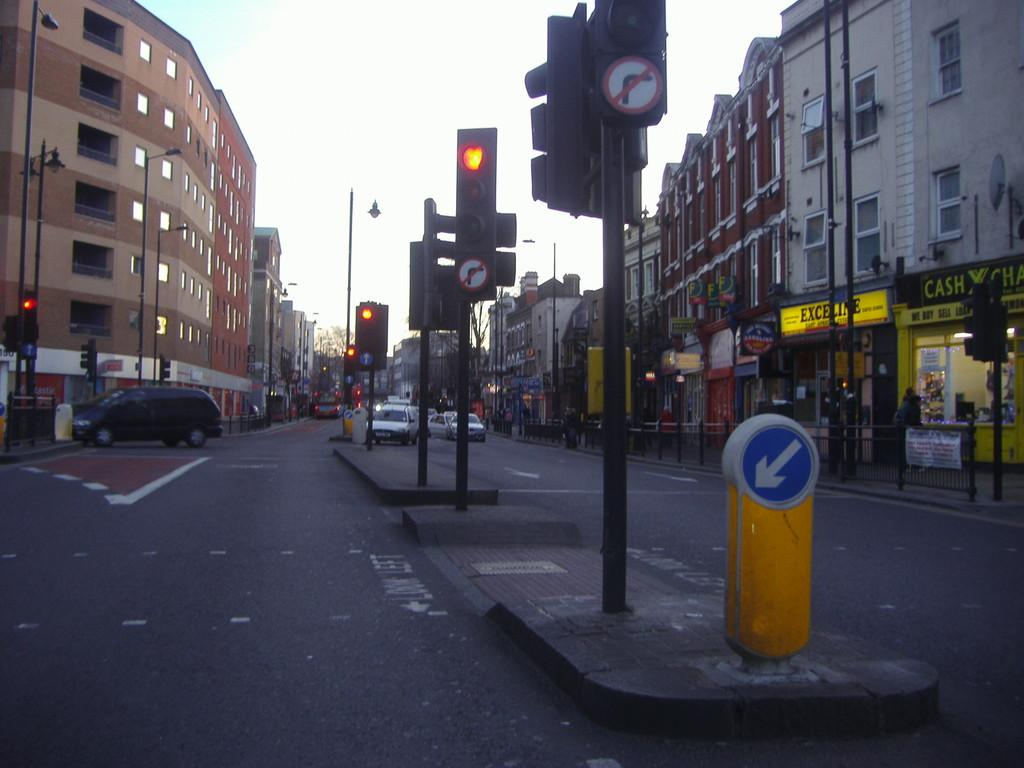<image>
Share a concise interpretation of the image provided. A road where there are shopping stores on the right including Cash X Change/ 